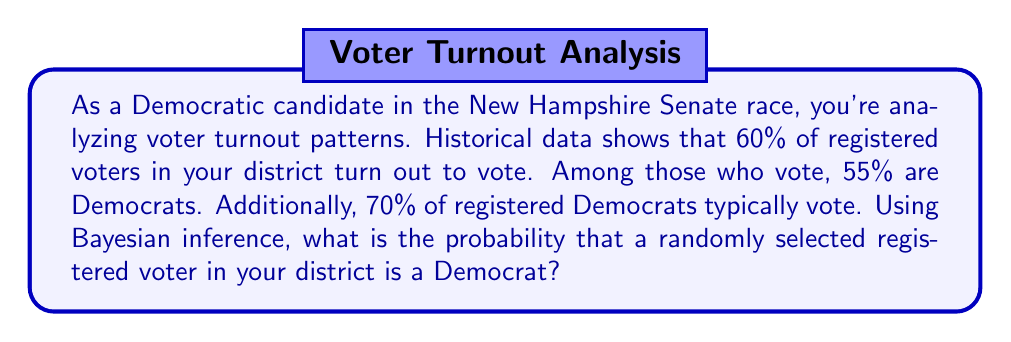Provide a solution to this math problem. Let's approach this problem using Bayesian inference:

1) Define our events:
   A: The voter is a Democrat
   B: The voter turns out to vote

2) We're given the following probabilities:
   $P(B) = 0.60$ (60% of registered voters turn out)
   $P(A|B) = 0.55$ (55% of those who vote are Democrats)
   $P(B|A) = 0.70$ (70% of Democrats vote)

3) We want to find $P(A)$, the probability that a randomly selected voter is a Democrat.

4) We can use Bayes' Theorem:

   $$P(A|B) = \frac{P(B|A) \cdot P(A)}{P(B)}$$

5) Rearranging this equation:

   $$P(A) = \frac{P(A|B) \cdot P(B)}{P(B|A)}$$

6) Substituting our known values:

   $$P(A) = \frac{0.55 \cdot 0.60}{0.70}$$

7) Calculating:

   $$P(A) = \frac{0.33}{0.70} = 0.4714$$

Therefore, the probability that a randomly selected registered voter in your district is a Democrat is approximately 0.4714 or 47.14%.
Answer: 0.4714 